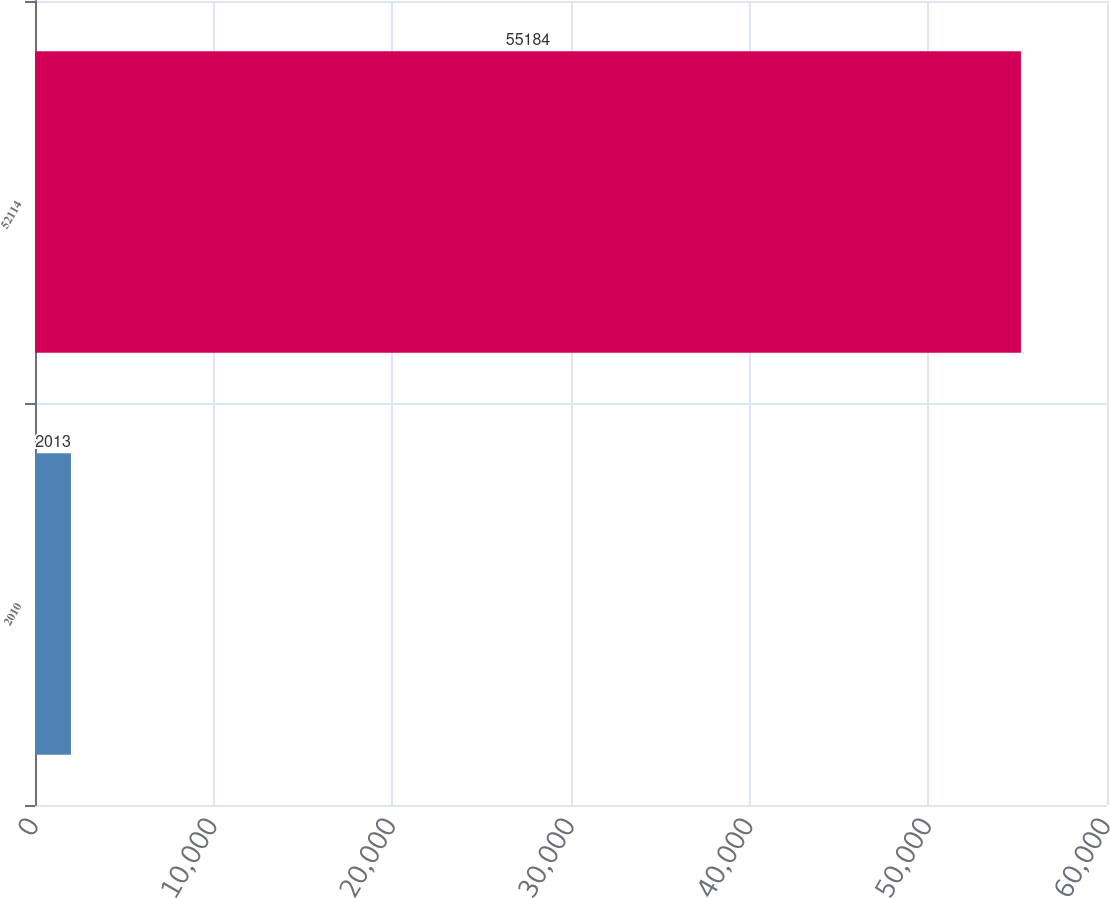Convert chart to OTSL. <chart><loc_0><loc_0><loc_500><loc_500><bar_chart><fcel>2010<fcel>52114<nl><fcel>2013<fcel>55184<nl></chart> 